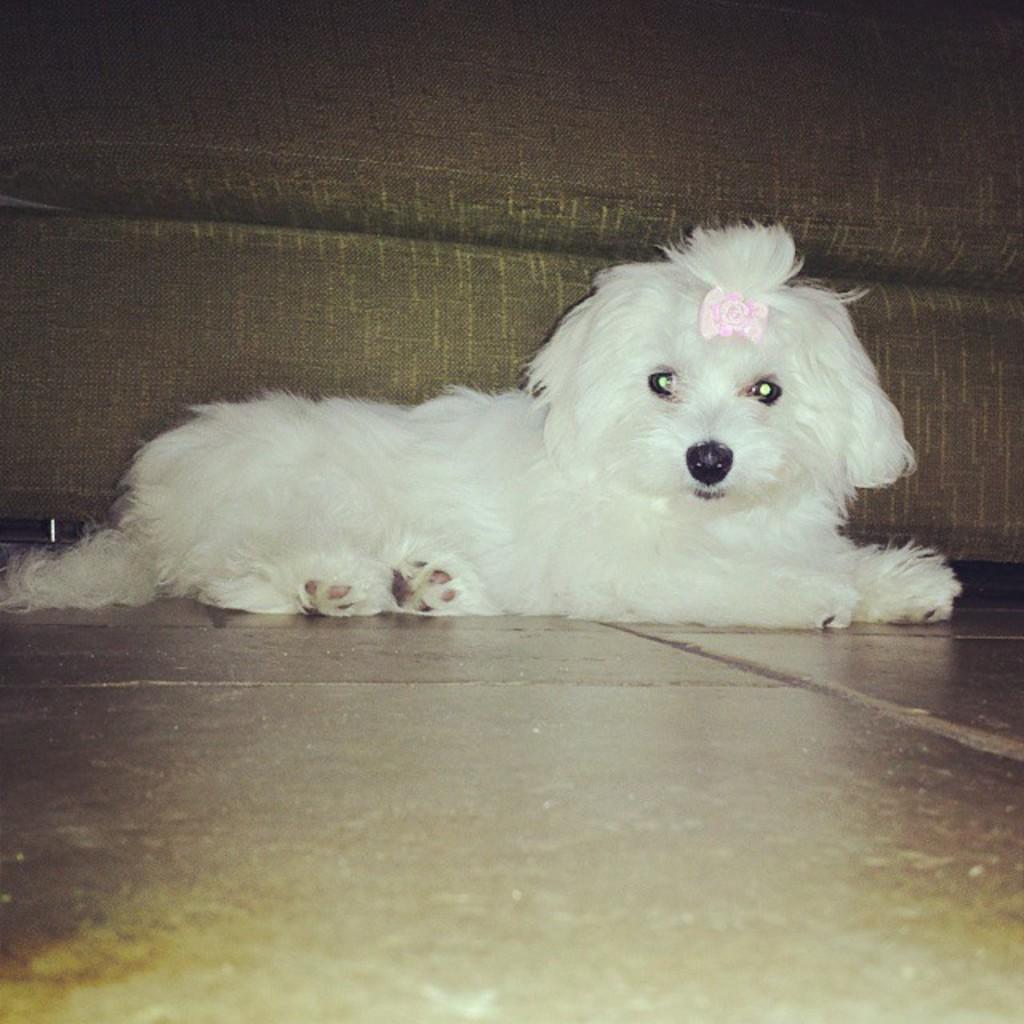Please provide a concise description of this image. In this image I can see a white dog sitting on the floor. 